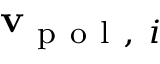Convert formula to latex. <formula><loc_0><loc_0><loc_500><loc_500>v _ { p o l , i }</formula> 